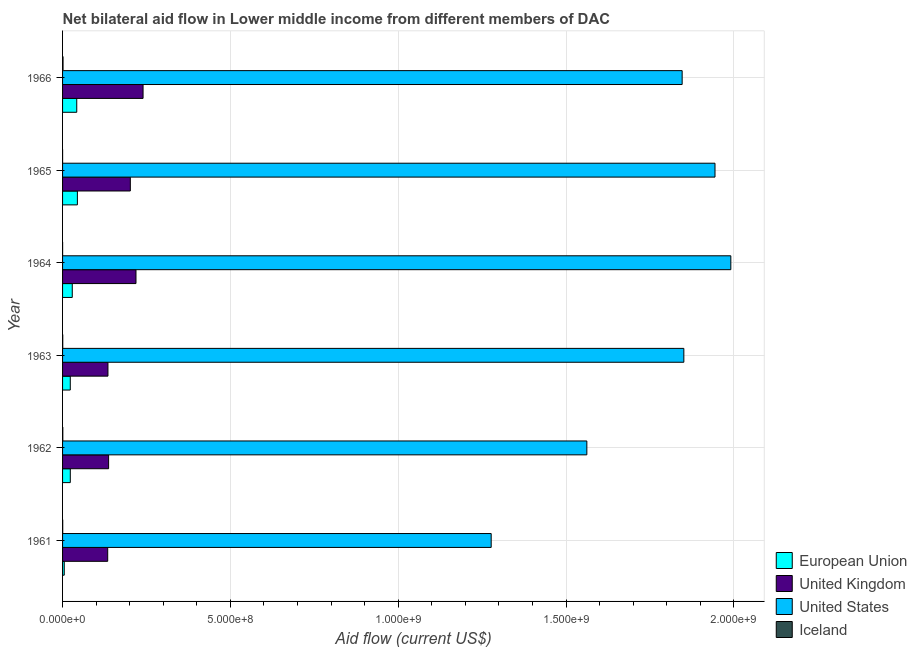How many different coloured bars are there?
Your answer should be very brief. 4. How many groups of bars are there?
Ensure brevity in your answer.  6. Are the number of bars on each tick of the Y-axis equal?
Keep it short and to the point. Yes. How many bars are there on the 3rd tick from the bottom?
Your answer should be compact. 4. In how many cases, is the number of bars for a given year not equal to the number of legend labels?
Your answer should be very brief. 0. What is the amount of aid given by eu in 1966?
Your response must be concise. 4.23e+07. Across all years, what is the maximum amount of aid given by uk?
Provide a succinct answer. 2.40e+08. Across all years, what is the minimum amount of aid given by eu?
Your answer should be compact. 5.04e+06. In which year was the amount of aid given by iceland maximum?
Give a very brief answer. 1966. What is the total amount of aid given by iceland in the graph?
Offer a very short reply. 3.31e+06. What is the difference between the amount of aid given by iceland in 1962 and that in 1964?
Offer a terse response. 6.10e+05. What is the difference between the amount of aid given by iceland in 1966 and the amount of aid given by uk in 1962?
Your response must be concise. -1.36e+08. What is the average amount of aid given by iceland per year?
Give a very brief answer. 5.52e+05. In the year 1965, what is the difference between the amount of aid given by uk and amount of aid given by iceland?
Make the answer very short. 2.02e+08. What is the ratio of the amount of aid given by iceland in 1962 to that in 1966?
Give a very brief answer. 0.51. Is the amount of aid given by iceland in 1961 less than that in 1966?
Give a very brief answer. Yes. What is the difference between the highest and the second highest amount of aid given by eu?
Your answer should be compact. 1.88e+06. What is the difference between the highest and the lowest amount of aid given by uk?
Keep it short and to the point. 1.05e+08. What does the 2nd bar from the top in 1963 represents?
Your response must be concise. United States. What does the 2nd bar from the bottom in 1961 represents?
Provide a short and direct response. United Kingdom. How many bars are there?
Keep it short and to the point. 24. What is the difference between two consecutive major ticks on the X-axis?
Offer a very short reply. 5.00e+08. Are the values on the major ticks of X-axis written in scientific E-notation?
Ensure brevity in your answer.  Yes. Does the graph contain any zero values?
Ensure brevity in your answer.  No. Where does the legend appear in the graph?
Provide a short and direct response. Bottom right. How are the legend labels stacked?
Offer a terse response. Vertical. What is the title of the graph?
Give a very brief answer. Net bilateral aid flow in Lower middle income from different members of DAC. What is the label or title of the Y-axis?
Give a very brief answer. Year. What is the Aid flow (current US$) of European Union in 1961?
Provide a short and direct response. 5.04e+06. What is the Aid flow (current US$) in United Kingdom in 1961?
Make the answer very short. 1.34e+08. What is the Aid flow (current US$) of United States in 1961?
Ensure brevity in your answer.  1.28e+09. What is the Aid flow (current US$) of European Union in 1962?
Ensure brevity in your answer.  2.30e+07. What is the Aid flow (current US$) of United Kingdom in 1962?
Keep it short and to the point. 1.37e+08. What is the Aid flow (current US$) in United States in 1962?
Your response must be concise. 1.56e+09. What is the Aid flow (current US$) of Iceland in 1962?
Make the answer very short. 7.20e+05. What is the Aid flow (current US$) in European Union in 1963?
Ensure brevity in your answer.  2.30e+07. What is the Aid flow (current US$) in United Kingdom in 1963?
Offer a terse response. 1.35e+08. What is the Aid flow (current US$) of United States in 1963?
Provide a short and direct response. 1.85e+09. What is the Aid flow (current US$) in Iceland in 1963?
Your answer should be very brief. 5.30e+05. What is the Aid flow (current US$) of European Union in 1964?
Make the answer very short. 2.89e+07. What is the Aid flow (current US$) of United Kingdom in 1964?
Your answer should be very brief. 2.19e+08. What is the Aid flow (current US$) in United States in 1964?
Offer a terse response. 1.99e+09. What is the Aid flow (current US$) in European Union in 1965?
Provide a short and direct response. 4.42e+07. What is the Aid flow (current US$) of United Kingdom in 1965?
Provide a succinct answer. 2.02e+08. What is the Aid flow (current US$) in United States in 1965?
Give a very brief answer. 1.94e+09. What is the Aid flow (current US$) in Iceland in 1965?
Give a very brief answer. 6.00e+04. What is the Aid flow (current US$) of European Union in 1966?
Provide a short and direct response. 4.23e+07. What is the Aid flow (current US$) of United Kingdom in 1966?
Provide a succinct answer. 2.40e+08. What is the Aid flow (current US$) in United States in 1966?
Your answer should be compact. 1.85e+09. What is the Aid flow (current US$) of Iceland in 1966?
Your answer should be compact. 1.42e+06. Across all years, what is the maximum Aid flow (current US$) in European Union?
Your response must be concise. 4.42e+07. Across all years, what is the maximum Aid flow (current US$) of United Kingdom?
Offer a terse response. 2.40e+08. Across all years, what is the maximum Aid flow (current US$) of United States?
Ensure brevity in your answer.  1.99e+09. Across all years, what is the maximum Aid flow (current US$) in Iceland?
Offer a terse response. 1.42e+06. Across all years, what is the minimum Aid flow (current US$) of European Union?
Offer a very short reply. 5.04e+06. Across all years, what is the minimum Aid flow (current US$) of United Kingdom?
Give a very brief answer. 1.34e+08. Across all years, what is the minimum Aid flow (current US$) in United States?
Ensure brevity in your answer.  1.28e+09. Across all years, what is the minimum Aid flow (current US$) in Iceland?
Provide a succinct answer. 6.00e+04. What is the total Aid flow (current US$) in European Union in the graph?
Your response must be concise. 1.66e+08. What is the total Aid flow (current US$) of United Kingdom in the graph?
Ensure brevity in your answer.  1.07e+09. What is the total Aid flow (current US$) in United States in the graph?
Offer a very short reply. 1.05e+1. What is the total Aid flow (current US$) in Iceland in the graph?
Ensure brevity in your answer.  3.31e+06. What is the difference between the Aid flow (current US$) in European Union in 1961 and that in 1962?
Your answer should be very brief. -1.80e+07. What is the difference between the Aid flow (current US$) of United Kingdom in 1961 and that in 1962?
Give a very brief answer. -2.70e+06. What is the difference between the Aid flow (current US$) of United States in 1961 and that in 1962?
Give a very brief answer. -2.85e+08. What is the difference between the Aid flow (current US$) in European Union in 1961 and that in 1963?
Give a very brief answer. -1.79e+07. What is the difference between the Aid flow (current US$) of United Kingdom in 1961 and that in 1963?
Offer a terse response. -7.10e+05. What is the difference between the Aid flow (current US$) in United States in 1961 and that in 1963?
Offer a terse response. -5.74e+08. What is the difference between the Aid flow (current US$) of European Union in 1961 and that in 1964?
Provide a succinct answer. -2.39e+07. What is the difference between the Aid flow (current US$) in United Kingdom in 1961 and that in 1964?
Ensure brevity in your answer.  -8.42e+07. What is the difference between the Aid flow (current US$) of United States in 1961 and that in 1964?
Give a very brief answer. -7.14e+08. What is the difference between the Aid flow (current US$) of European Union in 1961 and that in 1965?
Provide a short and direct response. -3.91e+07. What is the difference between the Aid flow (current US$) in United Kingdom in 1961 and that in 1965?
Your response must be concise. -6.74e+07. What is the difference between the Aid flow (current US$) in United States in 1961 and that in 1965?
Provide a short and direct response. -6.67e+08. What is the difference between the Aid flow (current US$) of European Union in 1961 and that in 1966?
Your response must be concise. -3.72e+07. What is the difference between the Aid flow (current US$) of United Kingdom in 1961 and that in 1966?
Ensure brevity in your answer.  -1.05e+08. What is the difference between the Aid flow (current US$) of United States in 1961 and that in 1966?
Your response must be concise. -5.69e+08. What is the difference between the Aid flow (current US$) in Iceland in 1961 and that in 1966?
Give a very brief answer. -9.50e+05. What is the difference between the Aid flow (current US$) of United Kingdom in 1962 and that in 1963?
Ensure brevity in your answer.  1.99e+06. What is the difference between the Aid flow (current US$) in United States in 1962 and that in 1963?
Give a very brief answer. -2.89e+08. What is the difference between the Aid flow (current US$) in European Union in 1962 and that in 1964?
Your answer should be compact. -5.88e+06. What is the difference between the Aid flow (current US$) of United Kingdom in 1962 and that in 1964?
Provide a short and direct response. -8.15e+07. What is the difference between the Aid flow (current US$) of United States in 1962 and that in 1964?
Make the answer very short. -4.29e+08. What is the difference between the Aid flow (current US$) in European Union in 1962 and that in 1965?
Offer a terse response. -2.11e+07. What is the difference between the Aid flow (current US$) of United Kingdom in 1962 and that in 1965?
Your response must be concise. -6.47e+07. What is the difference between the Aid flow (current US$) in United States in 1962 and that in 1965?
Your response must be concise. -3.82e+08. What is the difference between the Aid flow (current US$) in European Union in 1962 and that in 1966?
Offer a terse response. -1.92e+07. What is the difference between the Aid flow (current US$) of United Kingdom in 1962 and that in 1966?
Provide a short and direct response. -1.03e+08. What is the difference between the Aid flow (current US$) in United States in 1962 and that in 1966?
Your response must be concise. -2.84e+08. What is the difference between the Aid flow (current US$) in Iceland in 1962 and that in 1966?
Your answer should be compact. -7.00e+05. What is the difference between the Aid flow (current US$) of European Union in 1963 and that in 1964?
Make the answer very short. -5.95e+06. What is the difference between the Aid flow (current US$) of United Kingdom in 1963 and that in 1964?
Your answer should be very brief. -8.35e+07. What is the difference between the Aid flow (current US$) in United States in 1963 and that in 1964?
Provide a succinct answer. -1.40e+08. What is the difference between the Aid flow (current US$) of European Union in 1963 and that in 1965?
Provide a succinct answer. -2.12e+07. What is the difference between the Aid flow (current US$) in United Kingdom in 1963 and that in 1965?
Ensure brevity in your answer.  -6.67e+07. What is the difference between the Aid flow (current US$) of United States in 1963 and that in 1965?
Your answer should be very brief. -9.29e+07. What is the difference between the Aid flow (current US$) in Iceland in 1963 and that in 1965?
Offer a very short reply. 4.70e+05. What is the difference between the Aid flow (current US$) of European Union in 1963 and that in 1966?
Make the answer very short. -1.93e+07. What is the difference between the Aid flow (current US$) of United Kingdom in 1963 and that in 1966?
Offer a very short reply. -1.05e+08. What is the difference between the Aid flow (current US$) of United States in 1963 and that in 1966?
Offer a terse response. 5.02e+06. What is the difference between the Aid flow (current US$) of Iceland in 1963 and that in 1966?
Offer a terse response. -8.90e+05. What is the difference between the Aid flow (current US$) of European Union in 1964 and that in 1965?
Keep it short and to the point. -1.52e+07. What is the difference between the Aid flow (current US$) in United Kingdom in 1964 and that in 1965?
Keep it short and to the point. 1.68e+07. What is the difference between the Aid flow (current US$) of United States in 1964 and that in 1965?
Offer a terse response. 4.71e+07. What is the difference between the Aid flow (current US$) in European Union in 1964 and that in 1966?
Give a very brief answer. -1.34e+07. What is the difference between the Aid flow (current US$) in United Kingdom in 1964 and that in 1966?
Your answer should be very brief. -2.11e+07. What is the difference between the Aid flow (current US$) of United States in 1964 and that in 1966?
Provide a short and direct response. 1.45e+08. What is the difference between the Aid flow (current US$) in Iceland in 1964 and that in 1966?
Your answer should be very brief. -1.31e+06. What is the difference between the Aid flow (current US$) of European Union in 1965 and that in 1966?
Make the answer very short. 1.88e+06. What is the difference between the Aid flow (current US$) of United Kingdom in 1965 and that in 1966?
Your answer should be compact. -3.79e+07. What is the difference between the Aid flow (current US$) in United States in 1965 and that in 1966?
Keep it short and to the point. 9.79e+07. What is the difference between the Aid flow (current US$) of Iceland in 1965 and that in 1966?
Offer a terse response. -1.36e+06. What is the difference between the Aid flow (current US$) in European Union in 1961 and the Aid flow (current US$) in United Kingdom in 1962?
Provide a short and direct response. -1.32e+08. What is the difference between the Aid flow (current US$) of European Union in 1961 and the Aid flow (current US$) of United States in 1962?
Your response must be concise. -1.56e+09. What is the difference between the Aid flow (current US$) of European Union in 1961 and the Aid flow (current US$) of Iceland in 1962?
Keep it short and to the point. 4.32e+06. What is the difference between the Aid flow (current US$) in United Kingdom in 1961 and the Aid flow (current US$) in United States in 1962?
Keep it short and to the point. -1.43e+09. What is the difference between the Aid flow (current US$) in United Kingdom in 1961 and the Aid flow (current US$) in Iceland in 1962?
Provide a succinct answer. 1.34e+08. What is the difference between the Aid flow (current US$) in United States in 1961 and the Aid flow (current US$) in Iceland in 1962?
Offer a terse response. 1.28e+09. What is the difference between the Aid flow (current US$) in European Union in 1961 and the Aid flow (current US$) in United Kingdom in 1963?
Offer a terse response. -1.30e+08. What is the difference between the Aid flow (current US$) in European Union in 1961 and the Aid flow (current US$) in United States in 1963?
Keep it short and to the point. -1.85e+09. What is the difference between the Aid flow (current US$) in European Union in 1961 and the Aid flow (current US$) in Iceland in 1963?
Ensure brevity in your answer.  4.51e+06. What is the difference between the Aid flow (current US$) of United Kingdom in 1961 and the Aid flow (current US$) of United States in 1963?
Provide a short and direct response. -1.72e+09. What is the difference between the Aid flow (current US$) in United Kingdom in 1961 and the Aid flow (current US$) in Iceland in 1963?
Your answer should be very brief. 1.34e+08. What is the difference between the Aid flow (current US$) of United States in 1961 and the Aid flow (current US$) of Iceland in 1963?
Offer a terse response. 1.28e+09. What is the difference between the Aid flow (current US$) in European Union in 1961 and the Aid flow (current US$) in United Kingdom in 1964?
Give a very brief answer. -2.14e+08. What is the difference between the Aid flow (current US$) in European Union in 1961 and the Aid flow (current US$) in United States in 1964?
Keep it short and to the point. -1.99e+09. What is the difference between the Aid flow (current US$) of European Union in 1961 and the Aid flow (current US$) of Iceland in 1964?
Offer a terse response. 4.93e+06. What is the difference between the Aid flow (current US$) in United Kingdom in 1961 and the Aid flow (current US$) in United States in 1964?
Give a very brief answer. -1.86e+09. What is the difference between the Aid flow (current US$) in United Kingdom in 1961 and the Aid flow (current US$) in Iceland in 1964?
Give a very brief answer. 1.34e+08. What is the difference between the Aid flow (current US$) in United States in 1961 and the Aid flow (current US$) in Iceland in 1964?
Give a very brief answer. 1.28e+09. What is the difference between the Aid flow (current US$) in European Union in 1961 and the Aid flow (current US$) in United Kingdom in 1965?
Offer a terse response. -1.97e+08. What is the difference between the Aid flow (current US$) of European Union in 1961 and the Aid flow (current US$) of United States in 1965?
Your answer should be very brief. -1.94e+09. What is the difference between the Aid flow (current US$) of European Union in 1961 and the Aid flow (current US$) of Iceland in 1965?
Ensure brevity in your answer.  4.98e+06. What is the difference between the Aid flow (current US$) in United Kingdom in 1961 and the Aid flow (current US$) in United States in 1965?
Ensure brevity in your answer.  -1.81e+09. What is the difference between the Aid flow (current US$) of United Kingdom in 1961 and the Aid flow (current US$) of Iceland in 1965?
Keep it short and to the point. 1.34e+08. What is the difference between the Aid flow (current US$) in United States in 1961 and the Aid flow (current US$) in Iceland in 1965?
Your answer should be compact. 1.28e+09. What is the difference between the Aid flow (current US$) in European Union in 1961 and the Aid flow (current US$) in United Kingdom in 1966?
Your response must be concise. -2.35e+08. What is the difference between the Aid flow (current US$) of European Union in 1961 and the Aid flow (current US$) of United States in 1966?
Provide a short and direct response. -1.84e+09. What is the difference between the Aid flow (current US$) in European Union in 1961 and the Aid flow (current US$) in Iceland in 1966?
Ensure brevity in your answer.  3.62e+06. What is the difference between the Aid flow (current US$) in United Kingdom in 1961 and the Aid flow (current US$) in United States in 1966?
Your answer should be compact. -1.71e+09. What is the difference between the Aid flow (current US$) in United Kingdom in 1961 and the Aid flow (current US$) in Iceland in 1966?
Keep it short and to the point. 1.33e+08. What is the difference between the Aid flow (current US$) of United States in 1961 and the Aid flow (current US$) of Iceland in 1966?
Offer a terse response. 1.28e+09. What is the difference between the Aid flow (current US$) of European Union in 1962 and the Aid flow (current US$) of United Kingdom in 1963?
Offer a terse response. -1.12e+08. What is the difference between the Aid flow (current US$) in European Union in 1962 and the Aid flow (current US$) in United States in 1963?
Provide a succinct answer. -1.83e+09. What is the difference between the Aid flow (current US$) of European Union in 1962 and the Aid flow (current US$) of Iceland in 1963?
Provide a succinct answer. 2.25e+07. What is the difference between the Aid flow (current US$) of United Kingdom in 1962 and the Aid flow (current US$) of United States in 1963?
Your answer should be very brief. -1.71e+09. What is the difference between the Aid flow (current US$) in United Kingdom in 1962 and the Aid flow (current US$) in Iceland in 1963?
Ensure brevity in your answer.  1.37e+08. What is the difference between the Aid flow (current US$) of United States in 1962 and the Aid flow (current US$) of Iceland in 1963?
Provide a succinct answer. 1.56e+09. What is the difference between the Aid flow (current US$) in European Union in 1962 and the Aid flow (current US$) in United Kingdom in 1964?
Give a very brief answer. -1.96e+08. What is the difference between the Aid flow (current US$) of European Union in 1962 and the Aid flow (current US$) of United States in 1964?
Provide a succinct answer. -1.97e+09. What is the difference between the Aid flow (current US$) in European Union in 1962 and the Aid flow (current US$) in Iceland in 1964?
Offer a very short reply. 2.29e+07. What is the difference between the Aid flow (current US$) of United Kingdom in 1962 and the Aid flow (current US$) of United States in 1964?
Keep it short and to the point. -1.85e+09. What is the difference between the Aid flow (current US$) in United Kingdom in 1962 and the Aid flow (current US$) in Iceland in 1964?
Offer a terse response. 1.37e+08. What is the difference between the Aid flow (current US$) in United States in 1962 and the Aid flow (current US$) in Iceland in 1964?
Your answer should be very brief. 1.56e+09. What is the difference between the Aid flow (current US$) in European Union in 1962 and the Aid flow (current US$) in United Kingdom in 1965?
Give a very brief answer. -1.79e+08. What is the difference between the Aid flow (current US$) in European Union in 1962 and the Aid flow (current US$) in United States in 1965?
Give a very brief answer. -1.92e+09. What is the difference between the Aid flow (current US$) of European Union in 1962 and the Aid flow (current US$) of Iceland in 1965?
Make the answer very short. 2.30e+07. What is the difference between the Aid flow (current US$) of United Kingdom in 1962 and the Aid flow (current US$) of United States in 1965?
Give a very brief answer. -1.81e+09. What is the difference between the Aid flow (current US$) of United Kingdom in 1962 and the Aid flow (current US$) of Iceland in 1965?
Offer a very short reply. 1.37e+08. What is the difference between the Aid flow (current US$) in United States in 1962 and the Aid flow (current US$) in Iceland in 1965?
Offer a terse response. 1.56e+09. What is the difference between the Aid flow (current US$) in European Union in 1962 and the Aid flow (current US$) in United Kingdom in 1966?
Your answer should be very brief. -2.17e+08. What is the difference between the Aid flow (current US$) in European Union in 1962 and the Aid flow (current US$) in United States in 1966?
Your answer should be very brief. -1.82e+09. What is the difference between the Aid flow (current US$) of European Union in 1962 and the Aid flow (current US$) of Iceland in 1966?
Your answer should be compact. 2.16e+07. What is the difference between the Aid flow (current US$) in United Kingdom in 1962 and the Aid flow (current US$) in United States in 1966?
Ensure brevity in your answer.  -1.71e+09. What is the difference between the Aid flow (current US$) of United Kingdom in 1962 and the Aid flow (current US$) of Iceland in 1966?
Ensure brevity in your answer.  1.36e+08. What is the difference between the Aid flow (current US$) in United States in 1962 and the Aid flow (current US$) in Iceland in 1966?
Keep it short and to the point. 1.56e+09. What is the difference between the Aid flow (current US$) of European Union in 1963 and the Aid flow (current US$) of United Kingdom in 1964?
Keep it short and to the point. -1.96e+08. What is the difference between the Aid flow (current US$) in European Union in 1963 and the Aid flow (current US$) in United States in 1964?
Offer a very short reply. -1.97e+09. What is the difference between the Aid flow (current US$) of European Union in 1963 and the Aid flow (current US$) of Iceland in 1964?
Provide a short and direct response. 2.29e+07. What is the difference between the Aid flow (current US$) in United Kingdom in 1963 and the Aid flow (current US$) in United States in 1964?
Your answer should be compact. -1.86e+09. What is the difference between the Aid flow (current US$) in United Kingdom in 1963 and the Aid flow (current US$) in Iceland in 1964?
Provide a short and direct response. 1.35e+08. What is the difference between the Aid flow (current US$) of United States in 1963 and the Aid flow (current US$) of Iceland in 1964?
Provide a short and direct response. 1.85e+09. What is the difference between the Aid flow (current US$) of European Union in 1963 and the Aid flow (current US$) of United Kingdom in 1965?
Offer a terse response. -1.79e+08. What is the difference between the Aid flow (current US$) in European Union in 1963 and the Aid flow (current US$) in United States in 1965?
Ensure brevity in your answer.  -1.92e+09. What is the difference between the Aid flow (current US$) of European Union in 1963 and the Aid flow (current US$) of Iceland in 1965?
Keep it short and to the point. 2.29e+07. What is the difference between the Aid flow (current US$) of United Kingdom in 1963 and the Aid flow (current US$) of United States in 1965?
Provide a succinct answer. -1.81e+09. What is the difference between the Aid flow (current US$) of United Kingdom in 1963 and the Aid flow (current US$) of Iceland in 1965?
Ensure brevity in your answer.  1.35e+08. What is the difference between the Aid flow (current US$) of United States in 1963 and the Aid flow (current US$) of Iceland in 1965?
Your response must be concise. 1.85e+09. What is the difference between the Aid flow (current US$) in European Union in 1963 and the Aid flow (current US$) in United Kingdom in 1966?
Your response must be concise. -2.17e+08. What is the difference between the Aid flow (current US$) of European Union in 1963 and the Aid flow (current US$) of United States in 1966?
Offer a terse response. -1.82e+09. What is the difference between the Aid flow (current US$) in European Union in 1963 and the Aid flow (current US$) in Iceland in 1966?
Ensure brevity in your answer.  2.16e+07. What is the difference between the Aid flow (current US$) of United Kingdom in 1963 and the Aid flow (current US$) of United States in 1966?
Make the answer very short. -1.71e+09. What is the difference between the Aid flow (current US$) of United Kingdom in 1963 and the Aid flow (current US$) of Iceland in 1966?
Offer a terse response. 1.34e+08. What is the difference between the Aid flow (current US$) of United States in 1963 and the Aid flow (current US$) of Iceland in 1966?
Your answer should be compact. 1.85e+09. What is the difference between the Aid flow (current US$) in European Union in 1964 and the Aid flow (current US$) in United Kingdom in 1965?
Your response must be concise. -1.73e+08. What is the difference between the Aid flow (current US$) in European Union in 1964 and the Aid flow (current US$) in United States in 1965?
Ensure brevity in your answer.  -1.91e+09. What is the difference between the Aid flow (current US$) of European Union in 1964 and the Aid flow (current US$) of Iceland in 1965?
Ensure brevity in your answer.  2.89e+07. What is the difference between the Aid flow (current US$) of United Kingdom in 1964 and the Aid flow (current US$) of United States in 1965?
Offer a terse response. -1.73e+09. What is the difference between the Aid flow (current US$) in United Kingdom in 1964 and the Aid flow (current US$) in Iceland in 1965?
Offer a terse response. 2.19e+08. What is the difference between the Aid flow (current US$) in United States in 1964 and the Aid flow (current US$) in Iceland in 1965?
Offer a terse response. 1.99e+09. What is the difference between the Aid flow (current US$) in European Union in 1964 and the Aid flow (current US$) in United Kingdom in 1966?
Provide a succinct answer. -2.11e+08. What is the difference between the Aid flow (current US$) of European Union in 1964 and the Aid flow (current US$) of United States in 1966?
Ensure brevity in your answer.  -1.82e+09. What is the difference between the Aid flow (current US$) in European Union in 1964 and the Aid flow (current US$) in Iceland in 1966?
Your response must be concise. 2.75e+07. What is the difference between the Aid flow (current US$) of United Kingdom in 1964 and the Aid flow (current US$) of United States in 1966?
Offer a very short reply. -1.63e+09. What is the difference between the Aid flow (current US$) in United Kingdom in 1964 and the Aid flow (current US$) in Iceland in 1966?
Give a very brief answer. 2.17e+08. What is the difference between the Aid flow (current US$) in United States in 1964 and the Aid flow (current US$) in Iceland in 1966?
Provide a short and direct response. 1.99e+09. What is the difference between the Aid flow (current US$) of European Union in 1965 and the Aid flow (current US$) of United Kingdom in 1966?
Your response must be concise. -1.96e+08. What is the difference between the Aid flow (current US$) of European Union in 1965 and the Aid flow (current US$) of United States in 1966?
Provide a succinct answer. -1.80e+09. What is the difference between the Aid flow (current US$) of European Union in 1965 and the Aid flow (current US$) of Iceland in 1966?
Your answer should be very brief. 4.27e+07. What is the difference between the Aid flow (current US$) of United Kingdom in 1965 and the Aid flow (current US$) of United States in 1966?
Offer a very short reply. -1.64e+09. What is the difference between the Aid flow (current US$) in United Kingdom in 1965 and the Aid flow (current US$) in Iceland in 1966?
Keep it short and to the point. 2.00e+08. What is the difference between the Aid flow (current US$) of United States in 1965 and the Aid flow (current US$) of Iceland in 1966?
Your answer should be very brief. 1.94e+09. What is the average Aid flow (current US$) of European Union per year?
Make the answer very short. 2.77e+07. What is the average Aid flow (current US$) of United Kingdom per year?
Make the answer very short. 1.78e+08. What is the average Aid flow (current US$) of United States per year?
Keep it short and to the point. 1.75e+09. What is the average Aid flow (current US$) of Iceland per year?
Your answer should be very brief. 5.52e+05. In the year 1961, what is the difference between the Aid flow (current US$) of European Union and Aid flow (current US$) of United Kingdom?
Your answer should be very brief. -1.29e+08. In the year 1961, what is the difference between the Aid flow (current US$) in European Union and Aid flow (current US$) in United States?
Keep it short and to the point. -1.27e+09. In the year 1961, what is the difference between the Aid flow (current US$) of European Union and Aid flow (current US$) of Iceland?
Ensure brevity in your answer.  4.57e+06. In the year 1961, what is the difference between the Aid flow (current US$) in United Kingdom and Aid flow (current US$) in United States?
Give a very brief answer. -1.14e+09. In the year 1961, what is the difference between the Aid flow (current US$) of United Kingdom and Aid flow (current US$) of Iceland?
Your response must be concise. 1.34e+08. In the year 1961, what is the difference between the Aid flow (current US$) of United States and Aid flow (current US$) of Iceland?
Provide a succinct answer. 1.28e+09. In the year 1962, what is the difference between the Aid flow (current US$) in European Union and Aid flow (current US$) in United Kingdom?
Your answer should be compact. -1.14e+08. In the year 1962, what is the difference between the Aid flow (current US$) in European Union and Aid flow (current US$) in United States?
Provide a short and direct response. -1.54e+09. In the year 1962, what is the difference between the Aid flow (current US$) in European Union and Aid flow (current US$) in Iceland?
Keep it short and to the point. 2.23e+07. In the year 1962, what is the difference between the Aid flow (current US$) of United Kingdom and Aid flow (current US$) of United States?
Your response must be concise. -1.42e+09. In the year 1962, what is the difference between the Aid flow (current US$) of United Kingdom and Aid flow (current US$) of Iceland?
Give a very brief answer. 1.36e+08. In the year 1962, what is the difference between the Aid flow (current US$) of United States and Aid flow (current US$) of Iceland?
Provide a short and direct response. 1.56e+09. In the year 1963, what is the difference between the Aid flow (current US$) in European Union and Aid flow (current US$) in United Kingdom?
Offer a very short reply. -1.12e+08. In the year 1963, what is the difference between the Aid flow (current US$) of European Union and Aid flow (current US$) of United States?
Your answer should be compact. -1.83e+09. In the year 1963, what is the difference between the Aid flow (current US$) in European Union and Aid flow (current US$) in Iceland?
Your answer should be compact. 2.24e+07. In the year 1963, what is the difference between the Aid flow (current US$) in United Kingdom and Aid flow (current US$) in United States?
Offer a terse response. -1.72e+09. In the year 1963, what is the difference between the Aid flow (current US$) in United Kingdom and Aid flow (current US$) in Iceland?
Your answer should be compact. 1.35e+08. In the year 1963, what is the difference between the Aid flow (current US$) of United States and Aid flow (current US$) of Iceland?
Your response must be concise. 1.85e+09. In the year 1964, what is the difference between the Aid flow (current US$) in European Union and Aid flow (current US$) in United Kingdom?
Ensure brevity in your answer.  -1.90e+08. In the year 1964, what is the difference between the Aid flow (current US$) in European Union and Aid flow (current US$) in United States?
Your answer should be very brief. -1.96e+09. In the year 1964, what is the difference between the Aid flow (current US$) of European Union and Aid flow (current US$) of Iceland?
Your response must be concise. 2.88e+07. In the year 1964, what is the difference between the Aid flow (current US$) in United Kingdom and Aid flow (current US$) in United States?
Keep it short and to the point. -1.77e+09. In the year 1964, what is the difference between the Aid flow (current US$) of United Kingdom and Aid flow (current US$) of Iceland?
Ensure brevity in your answer.  2.19e+08. In the year 1964, what is the difference between the Aid flow (current US$) in United States and Aid flow (current US$) in Iceland?
Keep it short and to the point. 1.99e+09. In the year 1965, what is the difference between the Aid flow (current US$) in European Union and Aid flow (current US$) in United Kingdom?
Provide a succinct answer. -1.58e+08. In the year 1965, what is the difference between the Aid flow (current US$) in European Union and Aid flow (current US$) in United States?
Give a very brief answer. -1.90e+09. In the year 1965, what is the difference between the Aid flow (current US$) of European Union and Aid flow (current US$) of Iceland?
Ensure brevity in your answer.  4.41e+07. In the year 1965, what is the difference between the Aid flow (current US$) of United Kingdom and Aid flow (current US$) of United States?
Your answer should be compact. -1.74e+09. In the year 1965, what is the difference between the Aid flow (current US$) of United Kingdom and Aid flow (current US$) of Iceland?
Your answer should be very brief. 2.02e+08. In the year 1965, what is the difference between the Aid flow (current US$) in United States and Aid flow (current US$) in Iceland?
Your response must be concise. 1.94e+09. In the year 1966, what is the difference between the Aid flow (current US$) in European Union and Aid flow (current US$) in United Kingdom?
Offer a very short reply. -1.98e+08. In the year 1966, what is the difference between the Aid flow (current US$) in European Union and Aid flow (current US$) in United States?
Ensure brevity in your answer.  -1.80e+09. In the year 1966, what is the difference between the Aid flow (current US$) of European Union and Aid flow (current US$) of Iceland?
Ensure brevity in your answer.  4.08e+07. In the year 1966, what is the difference between the Aid flow (current US$) in United Kingdom and Aid flow (current US$) in United States?
Your answer should be very brief. -1.61e+09. In the year 1966, what is the difference between the Aid flow (current US$) in United Kingdom and Aid flow (current US$) in Iceland?
Your answer should be compact. 2.38e+08. In the year 1966, what is the difference between the Aid flow (current US$) of United States and Aid flow (current US$) of Iceland?
Provide a short and direct response. 1.84e+09. What is the ratio of the Aid flow (current US$) in European Union in 1961 to that in 1962?
Ensure brevity in your answer.  0.22. What is the ratio of the Aid flow (current US$) of United Kingdom in 1961 to that in 1962?
Provide a short and direct response. 0.98. What is the ratio of the Aid flow (current US$) of United States in 1961 to that in 1962?
Provide a short and direct response. 0.82. What is the ratio of the Aid flow (current US$) in Iceland in 1961 to that in 1962?
Give a very brief answer. 0.65. What is the ratio of the Aid flow (current US$) of European Union in 1961 to that in 1963?
Provide a short and direct response. 0.22. What is the ratio of the Aid flow (current US$) of United States in 1961 to that in 1963?
Ensure brevity in your answer.  0.69. What is the ratio of the Aid flow (current US$) of Iceland in 1961 to that in 1963?
Your answer should be compact. 0.89. What is the ratio of the Aid flow (current US$) in European Union in 1961 to that in 1964?
Make the answer very short. 0.17. What is the ratio of the Aid flow (current US$) of United Kingdom in 1961 to that in 1964?
Your answer should be very brief. 0.61. What is the ratio of the Aid flow (current US$) of United States in 1961 to that in 1964?
Ensure brevity in your answer.  0.64. What is the ratio of the Aid flow (current US$) of Iceland in 1961 to that in 1964?
Give a very brief answer. 4.27. What is the ratio of the Aid flow (current US$) in European Union in 1961 to that in 1965?
Make the answer very short. 0.11. What is the ratio of the Aid flow (current US$) in United Kingdom in 1961 to that in 1965?
Your response must be concise. 0.67. What is the ratio of the Aid flow (current US$) in United States in 1961 to that in 1965?
Provide a succinct answer. 0.66. What is the ratio of the Aid flow (current US$) in Iceland in 1961 to that in 1965?
Keep it short and to the point. 7.83. What is the ratio of the Aid flow (current US$) in European Union in 1961 to that in 1966?
Your answer should be very brief. 0.12. What is the ratio of the Aid flow (current US$) of United Kingdom in 1961 to that in 1966?
Offer a very short reply. 0.56. What is the ratio of the Aid flow (current US$) in United States in 1961 to that in 1966?
Give a very brief answer. 0.69. What is the ratio of the Aid flow (current US$) of Iceland in 1961 to that in 1966?
Keep it short and to the point. 0.33. What is the ratio of the Aid flow (current US$) in European Union in 1962 to that in 1963?
Provide a short and direct response. 1. What is the ratio of the Aid flow (current US$) of United Kingdom in 1962 to that in 1963?
Offer a very short reply. 1.01. What is the ratio of the Aid flow (current US$) of United States in 1962 to that in 1963?
Your answer should be compact. 0.84. What is the ratio of the Aid flow (current US$) in Iceland in 1962 to that in 1963?
Keep it short and to the point. 1.36. What is the ratio of the Aid flow (current US$) in European Union in 1962 to that in 1964?
Provide a short and direct response. 0.8. What is the ratio of the Aid flow (current US$) in United Kingdom in 1962 to that in 1964?
Offer a very short reply. 0.63. What is the ratio of the Aid flow (current US$) of United States in 1962 to that in 1964?
Give a very brief answer. 0.78. What is the ratio of the Aid flow (current US$) in Iceland in 1962 to that in 1964?
Your answer should be very brief. 6.55. What is the ratio of the Aid flow (current US$) of European Union in 1962 to that in 1965?
Ensure brevity in your answer.  0.52. What is the ratio of the Aid flow (current US$) of United Kingdom in 1962 to that in 1965?
Offer a terse response. 0.68. What is the ratio of the Aid flow (current US$) in United States in 1962 to that in 1965?
Offer a very short reply. 0.8. What is the ratio of the Aid flow (current US$) in European Union in 1962 to that in 1966?
Ensure brevity in your answer.  0.55. What is the ratio of the Aid flow (current US$) in United Kingdom in 1962 to that in 1966?
Provide a succinct answer. 0.57. What is the ratio of the Aid flow (current US$) in United States in 1962 to that in 1966?
Offer a terse response. 0.85. What is the ratio of the Aid flow (current US$) in Iceland in 1962 to that in 1966?
Your answer should be compact. 0.51. What is the ratio of the Aid flow (current US$) in European Union in 1963 to that in 1964?
Keep it short and to the point. 0.79. What is the ratio of the Aid flow (current US$) of United Kingdom in 1963 to that in 1964?
Offer a terse response. 0.62. What is the ratio of the Aid flow (current US$) of United States in 1963 to that in 1964?
Offer a terse response. 0.93. What is the ratio of the Aid flow (current US$) of Iceland in 1963 to that in 1964?
Offer a very short reply. 4.82. What is the ratio of the Aid flow (current US$) in European Union in 1963 to that in 1965?
Keep it short and to the point. 0.52. What is the ratio of the Aid flow (current US$) of United Kingdom in 1963 to that in 1965?
Give a very brief answer. 0.67. What is the ratio of the Aid flow (current US$) of United States in 1963 to that in 1965?
Make the answer very short. 0.95. What is the ratio of the Aid flow (current US$) of Iceland in 1963 to that in 1965?
Give a very brief answer. 8.83. What is the ratio of the Aid flow (current US$) in European Union in 1963 to that in 1966?
Your response must be concise. 0.54. What is the ratio of the Aid flow (current US$) in United Kingdom in 1963 to that in 1966?
Provide a short and direct response. 0.56. What is the ratio of the Aid flow (current US$) in Iceland in 1963 to that in 1966?
Keep it short and to the point. 0.37. What is the ratio of the Aid flow (current US$) of European Union in 1964 to that in 1965?
Your response must be concise. 0.66. What is the ratio of the Aid flow (current US$) in United Kingdom in 1964 to that in 1965?
Provide a short and direct response. 1.08. What is the ratio of the Aid flow (current US$) in United States in 1964 to that in 1965?
Keep it short and to the point. 1.02. What is the ratio of the Aid flow (current US$) of Iceland in 1964 to that in 1965?
Offer a very short reply. 1.83. What is the ratio of the Aid flow (current US$) in European Union in 1964 to that in 1966?
Make the answer very short. 0.68. What is the ratio of the Aid flow (current US$) in United Kingdom in 1964 to that in 1966?
Keep it short and to the point. 0.91. What is the ratio of the Aid flow (current US$) in United States in 1964 to that in 1966?
Make the answer very short. 1.08. What is the ratio of the Aid flow (current US$) in Iceland in 1964 to that in 1966?
Your answer should be compact. 0.08. What is the ratio of the Aid flow (current US$) in European Union in 1965 to that in 1966?
Provide a short and direct response. 1.04. What is the ratio of the Aid flow (current US$) of United Kingdom in 1965 to that in 1966?
Your response must be concise. 0.84. What is the ratio of the Aid flow (current US$) of United States in 1965 to that in 1966?
Your answer should be compact. 1.05. What is the ratio of the Aid flow (current US$) in Iceland in 1965 to that in 1966?
Give a very brief answer. 0.04. What is the difference between the highest and the second highest Aid flow (current US$) in European Union?
Offer a very short reply. 1.88e+06. What is the difference between the highest and the second highest Aid flow (current US$) in United Kingdom?
Your response must be concise. 2.11e+07. What is the difference between the highest and the second highest Aid flow (current US$) in United States?
Your answer should be very brief. 4.71e+07. What is the difference between the highest and the second highest Aid flow (current US$) of Iceland?
Give a very brief answer. 7.00e+05. What is the difference between the highest and the lowest Aid flow (current US$) in European Union?
Offer a terse response. 3.91e+07. What is the difference between the highest and the lowest Aid flow (current US$) in United Kingdom?
Provide a short and direct response. 1.05e+08. What is the difference between the highest and the lowest Aid flow (current US$) in United States?
Provide a succinct answer. 7.14e+08. What is the difference between the highest and the lowest Aid flow (current US$) in Iceland?
Keep it short and to the point. 1.36e+06. 